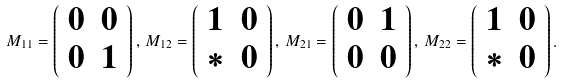Convert formula to latex. <formula><loc_0><loc_0><loc_500><loc_500>M _ { 1 1 } = \left ( \begin{array} { c c } 0 & 0 \\ 0 & 1 \end{array} \right ) , \, M _ { 1 2 } = \left ( \begin{array} { c c } 1 & 0 \\ * & 0 \end{array} \right ) , \, M _ { 2 1 } = \left ( \begin{array} { c c } 0 & 1 \\ 0 & 0 \end{array} \right ) , \, M _ { 2 2 } = \left ( \begin{array} { c c } 1 & 0 \\ * & 0 \end{array} \right ) .</formula> 